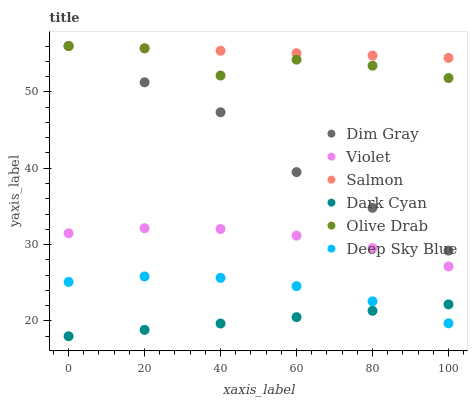Does Dark Cyan have the minimum area under the curve?
Answer yes or no. Yes. Does Salmon have the maximum area under the curve?
Answer yes or no. Yes. Does Deep Sky Blue have the minimum area under the curve?
Answer yes or no. No. Does Deep Sky Blue have the maximum area under the curve?
Answer yes or no. No. Is Dark Cyan the smoothest?
Answer yes or no. Yes. Is Olive Drab the roughest?
Answer yes or no. Yes. Is Salmon the smoothest?
Answer yes or no. No. Is Salmon the roughest?
Answer yes or no. No. Does Dark Cyan have the lowest value?
Answer yes or no. Yes. Does Deep Sky Blue have the lowest value?
Answer yes or no. No. Does Olive Drab have the highest value?
Answer yes or no. Yes. Does Deep Sky Blue have the highest value?
Answer yes or no. No. Is Deep Sky Blue less than Violet?
Answer yes or no. Yes. Is Dim Gray greater than Deep Sky Blue?
Answer yes or no. Yes. Does Dim Gray intersect Olive Drab?
Answer yes or no. Yes. Is Dim Gray less than Olive Drab?
Answer yes or no. No. Is Dim Gray greater than Olive Drab?
Answer yes or no. No. Does Deep Sky Blue intersect Violet?
Answer yes or no. No. 